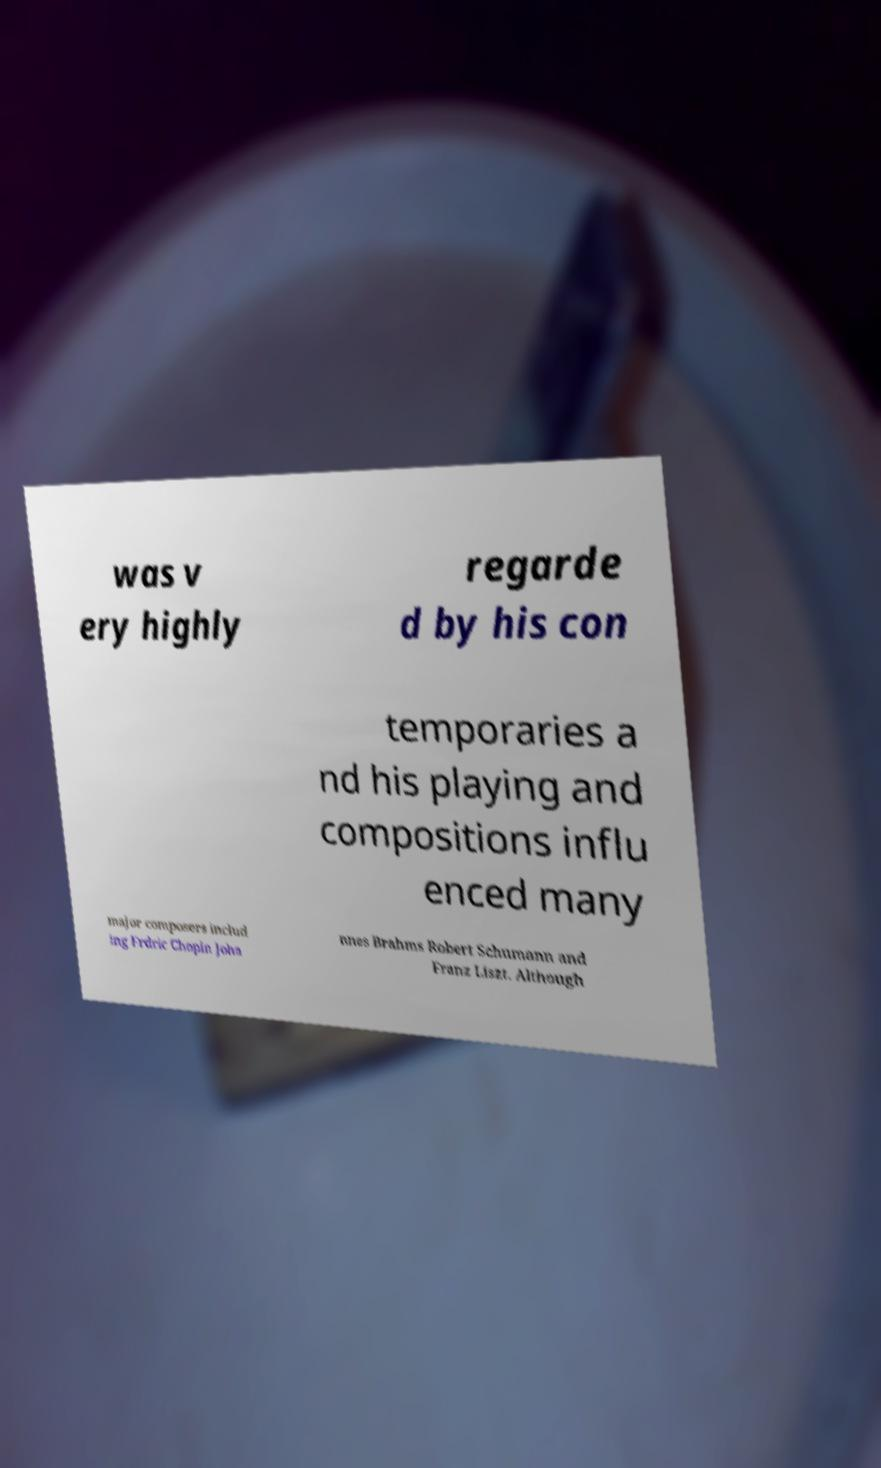Please read and relay the text visible in this image. What does it say? was v ery highly regarde d by his con temporaries a nd his playing and compositions influ enced many major composers includ ing Frdric Chopin Joha nnes Brahms Robert Schumann and Franz Liszt. Although 